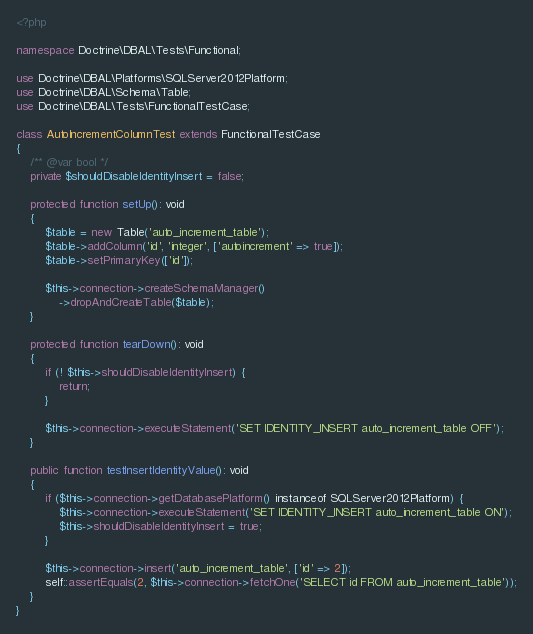<code> <loc_0><loc_0><loc_500><loc_500><_PHP_><?php

namespace Doctrine\DBAL\Tests\Functional;

use Doctrine\DBAL\Platforms\SQLServer2012Platform;
use Doctrine\DBAL\Schema\Table;
use Doctrine\DBAL\Tests\FunctionalTestCase;

class AutoIncrementColumnTest extends FunctionalTestCase
{
    /** @var bool */
    private $shouldDisableIdentityInsert = false;

    protected function setUp(): void
    {
        $table = new Table('auto_increment_table');
        $table->addColumn('id', 'integer', ['autoincrement' => true]);
        $table->setPrimaryKey(['id']);

        $this->connection->createSchemaManager()
            ->dropAndCreateTable($table);
    }

    protected function tearDown(): void
    {
        if (! $this->shouldDisableIdentityInsert) {
            return;
        }

        $this->connection->executeStatement('SET IDENTITY_INSERT auto_increment_table OFF');
    }

    public function testInsertIdentityValue(): void
    {
        if ($this->connection->getDatabasePlatform() instanceof SQLServer2012Platform) {
            $this->connection->executeStatement('SET IDENTITY_INSERT auto_increment_table ON');
            $this->shouldDisableIdentityInsert = true;
        }

        $this->connection->insert('auto_increment_table', ['id' => 2]);
        self::assertEquals(2, $this->connection->fetchOne('SELECT id FROM auto_increment_table'));
    }
}
</code> 